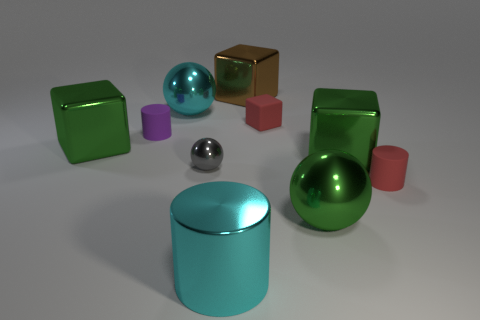Is there anything else that is the same size as the gray thing?
Make the answer very short. Yes. Do the metallic cylinder and the cylinder right of the brown shiny block have the same size?
Your answer should be very brief. No. What number of big brown balls are there?
Provide a succinct answer. 0. There is a green block to the left of the large brown shiny object; is its size the same as the metallic ball behind the small purple object?
Your answer should be compact. Yes. There is another tiny thing that is the same shape as the purple thing; what color is it?
Your response must be concise. Red. Does the purple object have the same shape as the gray shiny object?
Offer a terse response. No. There is a red rubber object that is the same shape as the purple object; what is its size?
Ensure brevity in your answer.  Small. What number of gray spheres are the same material as the brown object?
Ensure brevity in your answer.  1. What number of things are either large red cylinders or matte cylinders?
Provide a short and direct response. 2. There is a small cylinder right of the big brown object; is there a gray thing to the left of it?
Your answer should be very brief. Yes. 